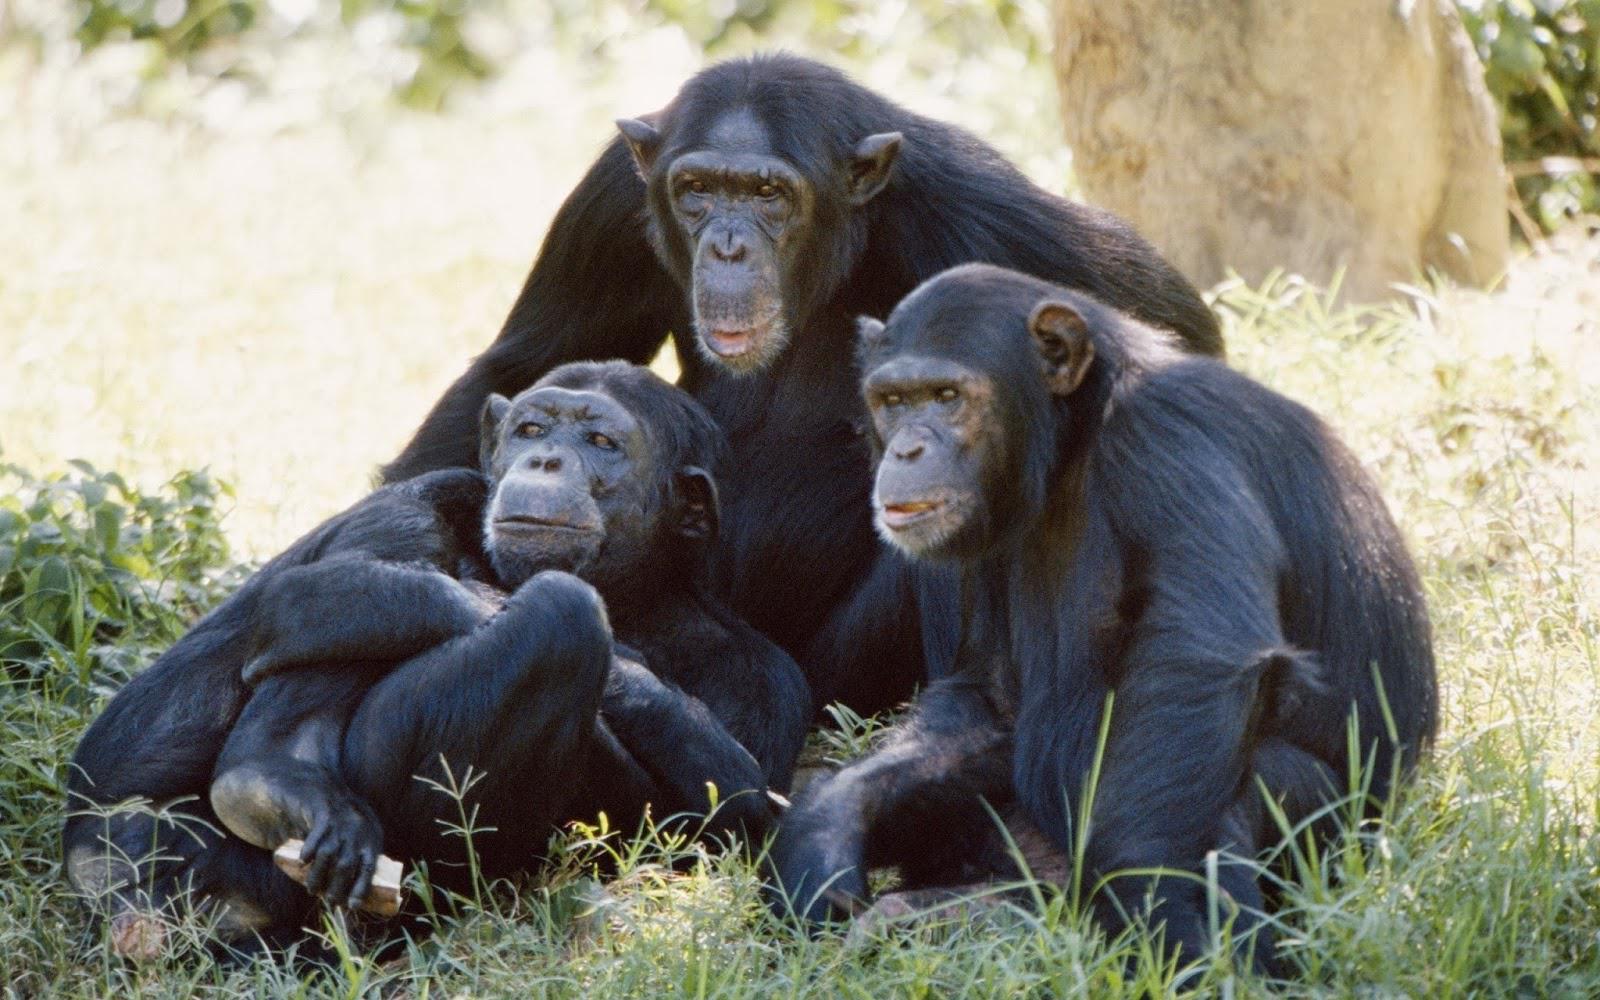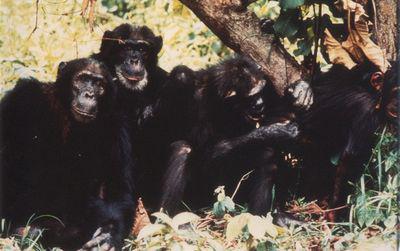The first image is the image on the left, the second image is the image on the right. For the images displayed, is the sentence "there are chimps with open wide moths displayed" factually correct? Answer yes or no. No. The first image is the image on the left, the second image is the image on the right. For the images shown, is this caption "An image shows a horizontal row of exactly five chimps." true? Answer yes or no. No. 